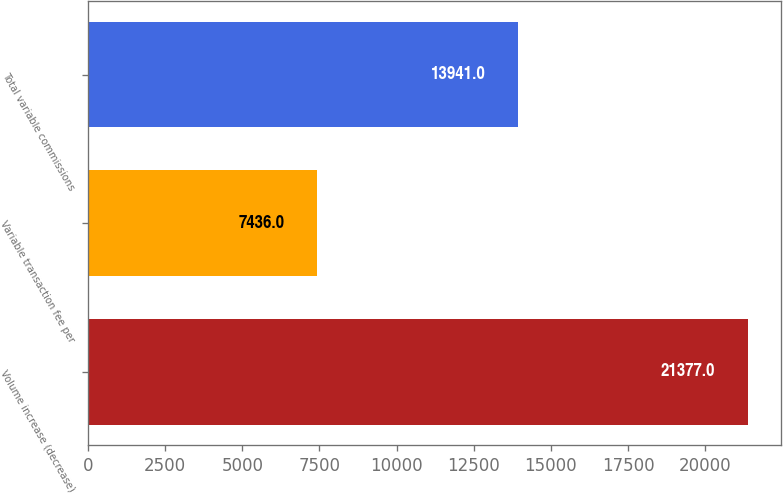Convert chart. <chart><loc_0><loc_0><loc_500><loc_500><bar_chart><fcel>Volume increase (decrease)<fcel>Variable transaction fee per<fcel>Total variable commissions<nl><fcel>21377<fcel>7436<fcel>13941<nl></chart> 